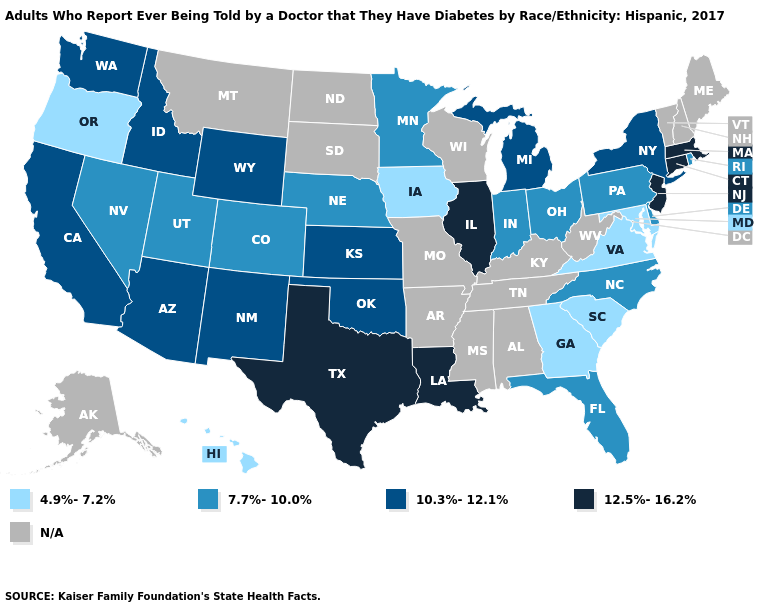Which states have the lowest value in the MidWest?
Keep it brief. Iowa. Does Pennsylvania have the lowest value in the USA?
Answer briefly. No. What is the value of Arizona?
Give a very brief answer. 10.3%-12.1%. Which states have the lowest value in the USA?
Answer briefly. Georgia, Hawaii, Iowa, Maryland, Oregon, South Carolina, Virginia. Does the map have missing data?
Give a very brief answer. Yes. Name the states that have a value in the range 12.5%-16.2%?
Quick response, please. Connecticut, Illinois, Louisiana, Massachusetts, New Jersey, Texas. What is the value of Colorado?
Be succinct. 7.7%-10.0%. Which states have the lowest value in the West?
Answer briefly. Hawaii, Oregon. Among the states that border Wyoming , does Colorado have the highest value?
Short answer required. No. Name the states that have a value in the range 10.3%-12.1%?
Be succinct. Arizona, California, Idaho, Kansas, Michigan, New Mexico, New York, Oklahoma, Washington, Wyoming. Does the map have missing data?
Answer briefly. Yes. What is the lowest value in the Northeast?
Concise answer only. 7.7%-10.0%. What is the value of Oklahoma?
Concise answer only. 10.3%-12.1%. Name the states that have a value in the range N/A?
Quick response, please. Alabama, Alaska, Arkansas, Kentucky, Maine, Mississippi, Missouri, Montana, New Hampshire, North Dakota, South Dakota, Tennessee, Vermont, West Virginia, Wisconsin. 